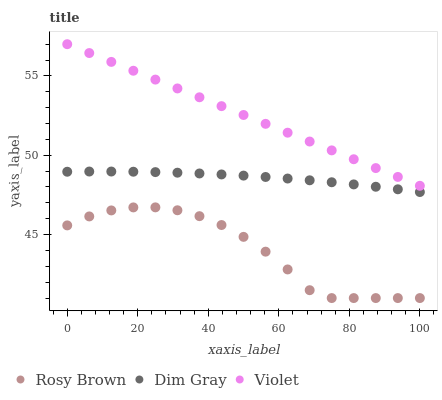Does Rosy Brown have the minimum area under the curve?
Answer yes or no. Yes. Does Violet have the maximum area under the curve?
Answer yes or no. Yes. Does Violet have the minimum area under the curve?
Answer yes or no. No. Does Rosy Brown have the maximum area under the curve?
Answer yes or no. No. Is Violet the smoothest?
Answer yes or no. Yes. Is Rosy Brown the roughest?
Answer yes or no. Yes. Is Rosy Brown the smoothest?
Answer yes or no. No. Is Violet the roughest?
Answer yes or no. No. Does Rosy Brown have the lowest value?
Answer yes or no. Yes. Does Violet have the lowest value?
Answer yes or no. No. Does Violet have the highest value?
Answer yes or no. Yes. Does Rosy Brown have the highest value?
Answer yes or no. No. Is Rosy Brown less than Violet?
Answer yes or no. Yes. Is Violet greater than Dim Gray?
Answer yes or no. Yes. Does Rosy Brown intersect Violet?
Answer yes or no. No. 